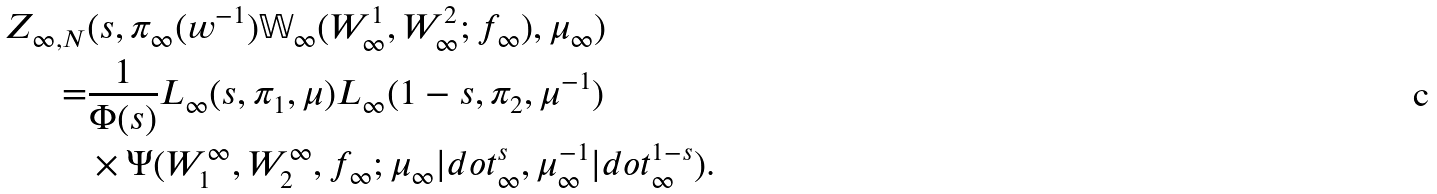Convert formula to latex. <formula><loc_0><loc_0><loc_500><loc_500>Z _ { \infty , N } & ( s , \pi _ { \infty } ( w ^ { - 1 } ) \mathbb { W } _ { \infty } ( W _ { \infty } ^ { 1 } , W _ { \infty } ^ { 2 } ; f _ { \infty } ) , \mu _ { \infty } ) \\ = & \frac { 1 } { \Phi ( s ) } L _ { \infty } ( s , \pi _ { 1 } , \mu ) L _ { \infty } ( 1 - s , \pi _ { 2 } , \mu ^ { - 1 } ) \\ & \times \Psi ( W ^ { \infty } _ { 1 } , W ^ { \infty } _ { 2 } , f _ { \infty } ; \mu _ { \infty } | d o t _ { \infty } ^ { s } , \mu _ { \infty } ^ { - 1 } | d o t _ { \infty } ^ { 1 - s } ) .</formula> 